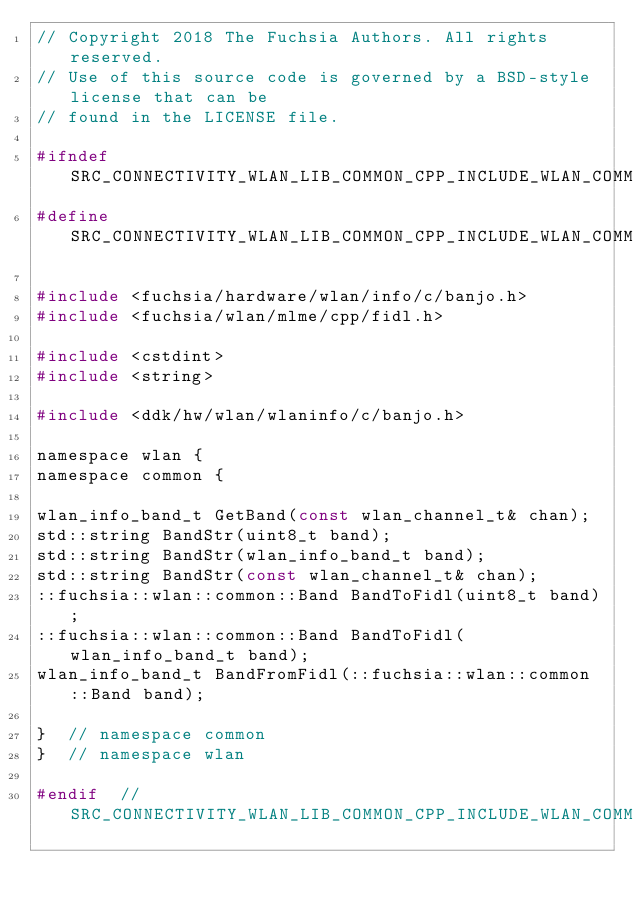Convert code to text. <code><loc_0><loc_0><loc_500><loc_500><_C_>// Copyright 2018 The Fuchsia Authors. All rights reserved.
// Use of this source code is governed by a BSD-style license that can be
// found in the LICENSE file.

#ifndef SRC_CONNECTIVITY_WLAN_LIB_COMMON_CPP_INCLUDE_WLAN_COMMON_BAND_H_
#define SRC_CONNECTIVITY_WLAN_LIB_COMMON_CPP_INCLUDE_WLAN_COMMON_BAND_H_

#include <fuchsia/hardware/wlan/info/c/banjo.h>
#include <fuchsia/wlan/mlme/cpp/fidl.h>

#include <cstdint>
#include <string>

#include <ddk/hw/wlan/wlaninfo/c/banjo.h>

namespace wlan {
namespace common {

wlan_info_band_t GetBand(const wlan_channel_t& chan);
std::string BandStr(uint8_t band);
std::string BandStr(wlan_info_band_t band);
std::string BandStr(const wlan_channel_t& chan);
::fuchsia::wlan::common::Band BandToFidl(uint8_t band);
::fuchsia::wlan::common::Band BandToFidl(wlan_info_band_t band);
wlan_info_band_t BandFromFidl(::fuchsia::wlan::common::Band band);

}  // namespace common
}  // namespace wlan

#endif  // SRC_CONNECTIVITY_WLAN_LIB_COMMON_CPP_INCLUDE_WLAN_COMMON_BAND_H_
</code> 